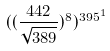<formula> <loc_0><loc_0><loc_500><loc_500>( ( \frac { 4 4 2 } { \sqrt { 3 8 9 } } ) ^ { 8 } ) ^ { 3 9 5 ^ { 1 } }</formula> 